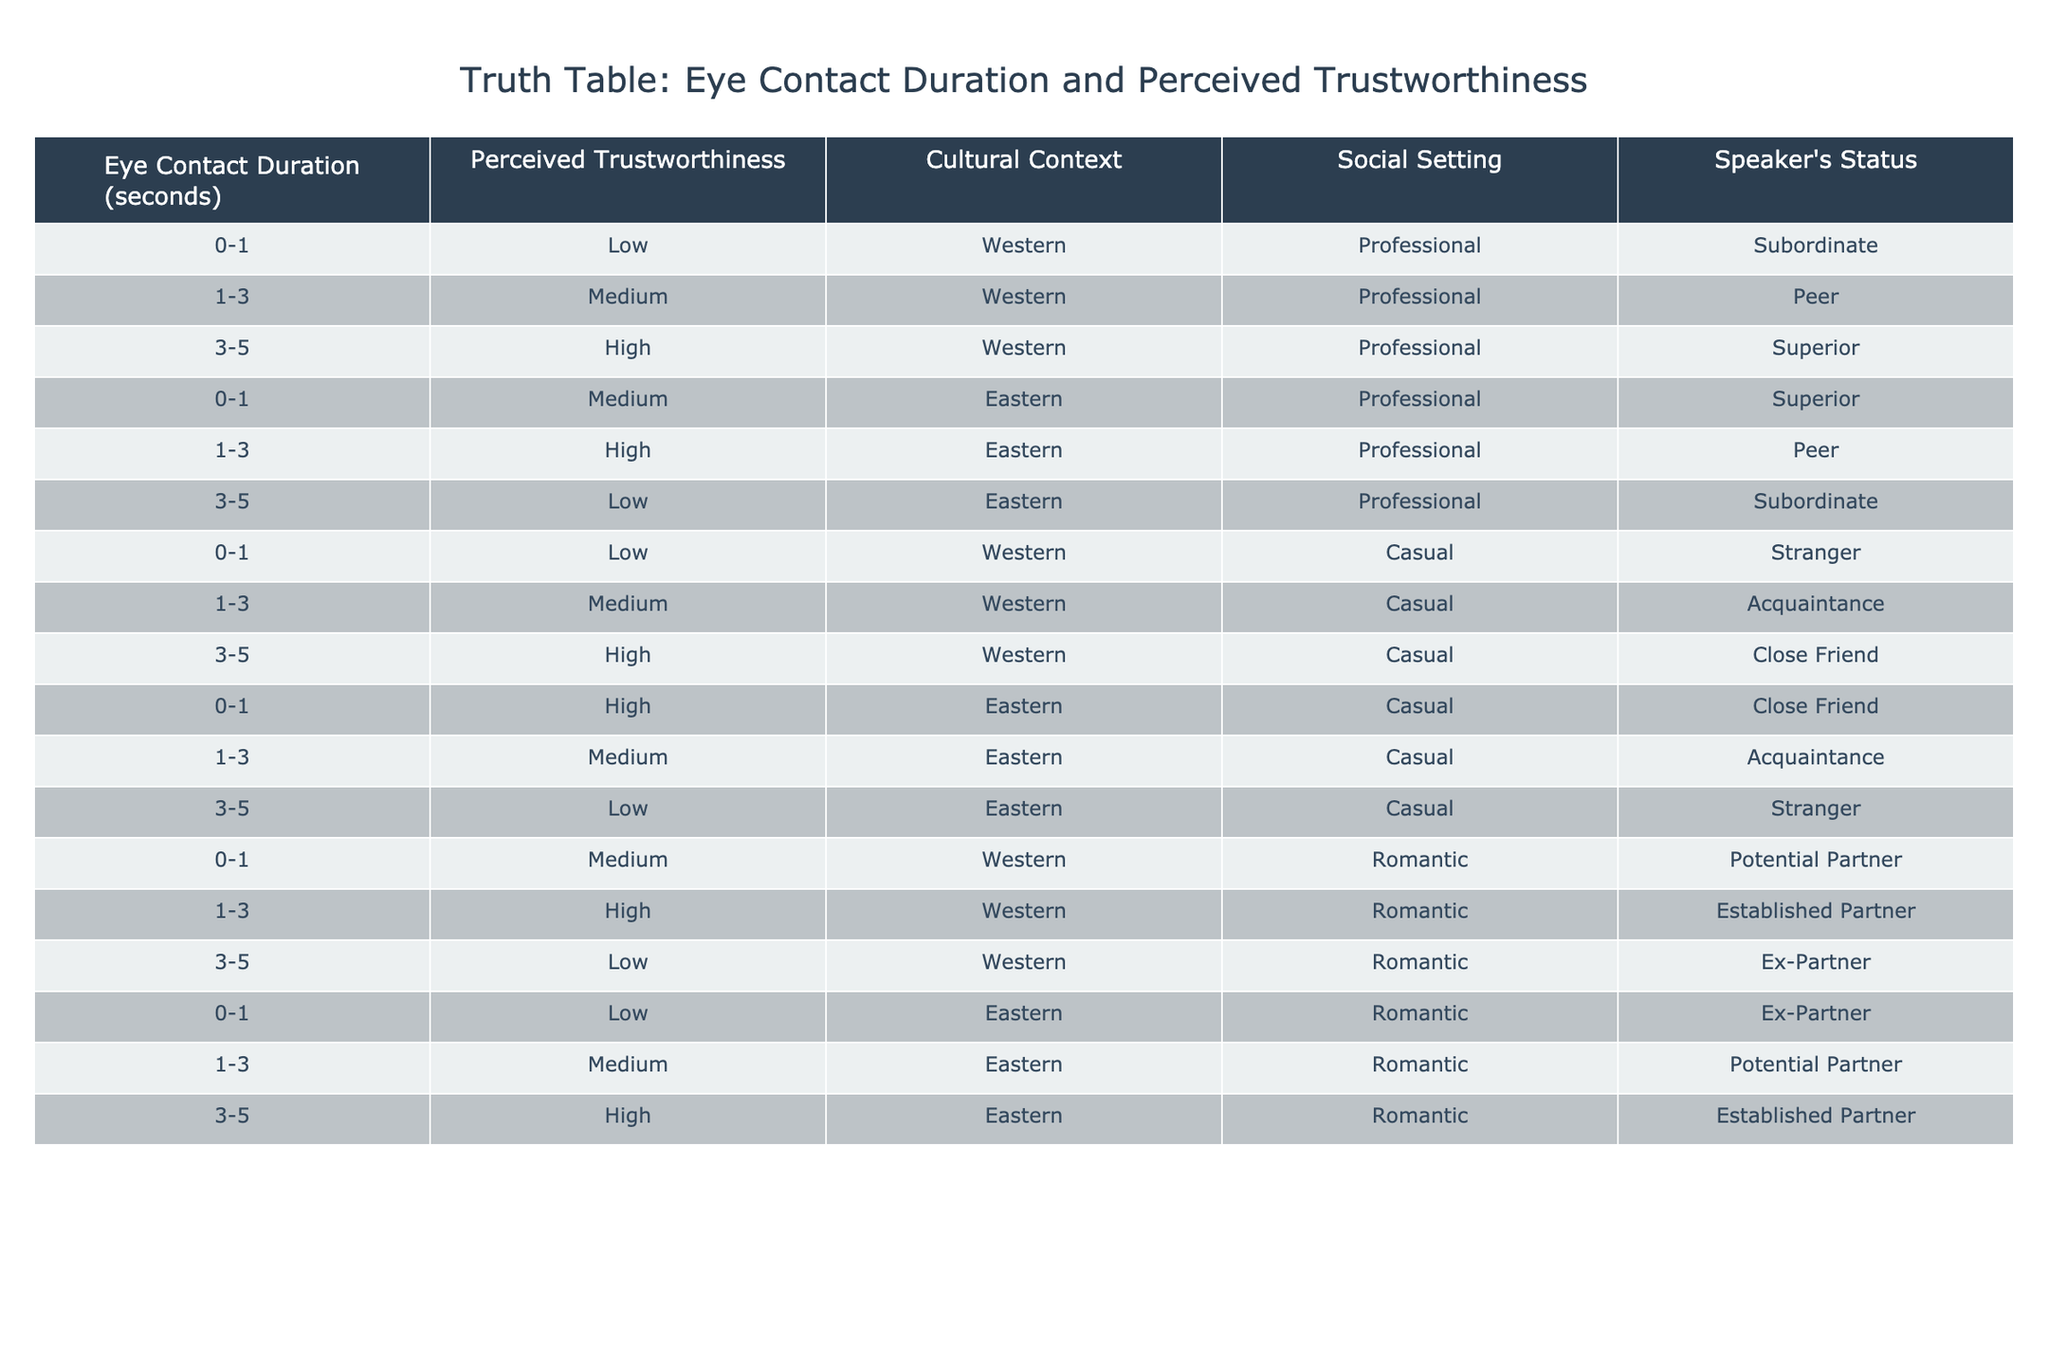What is the perceived trustworthiness when eye contact duration is between 1-3 seconds in a romantic setting with an established partner in a Western context? According to the table, in a romantic setting with an established partner in a Western context, the eye contact duration of 1-3 seconds is associated with high perceived trustworthiness.
Answer: High How many data points correspond to low perceived trustworthiness in the Eastern cultural context? From the table, there are three instances that indicate low perceived trustworthiness in the Eastern context: 0-1 seconds with a subordinate speaker in a professional setting, 3-5 seconds with a stranger in a casual setting, and 0-1 seconds with an ex-partner in a romantic setting. Therefore, the total is three data points.
Answer: 3 What is the average perceived trustworthiness for eye contact duration of 1-3 seconds across all cultural contexts? In the table, the perceived trustworthiness values for eye contact duration of 1-3 seconds are: medium (Western, professional) = 2, high (Eastern, professional) = 3, medium (Western, casual) = 2, high (Eastern, casual) = 3, medium (Western, romantic) = 2, high (Eastern, romantic) = 3. The total is 15, and there are six data points, so the average is 15/6 = 2.5.
Answer: 2.5 Is there a correlation between eye contact duration of 3-5 seconds and high perceived trustworthiness across all social settings? Yes, based on the table, in both the Western context and romantic setting, the duration of 3-5 seconds leads to high perceived trustworthiness. However, in the Eastern context, it is low in professional and casual settings. Therefore, there isn’t a consistent correlation across all social settings.
Answer: No Which social setting shows the highest perceived trustworthiness for a casual context when eye contact duration is 3-5 seconds? According to the table, in a casual setting, the eye contact duration of 3-5 seconds related to close friends is classified as high perceived trustworthiness in the Western cultural context, while it is low in the Eastern context. Thus, the highest perceived trustworthiness is during close friendships in the Western context for this duration.
Answer: Close Friend (Western) 